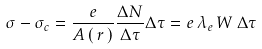Convert formula to latex. <formula><loc_0><loc_0><loc_500><loc_500>\sigma - \sigma _ { c } = \frac { e } { A \left ( \, r \, \right ) } \frac { \Delta N } { \Delta \tau } \Delta \tau = e \, \lambda _ { e } \, W \, \Delta \tau</formula> 